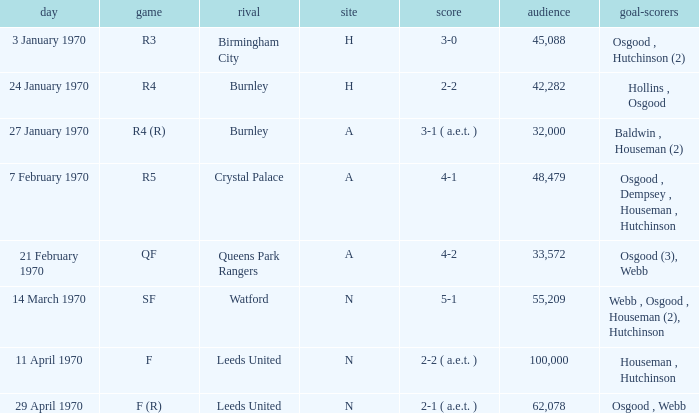What round was the game with a result of 5-1 at N venue? SF. 